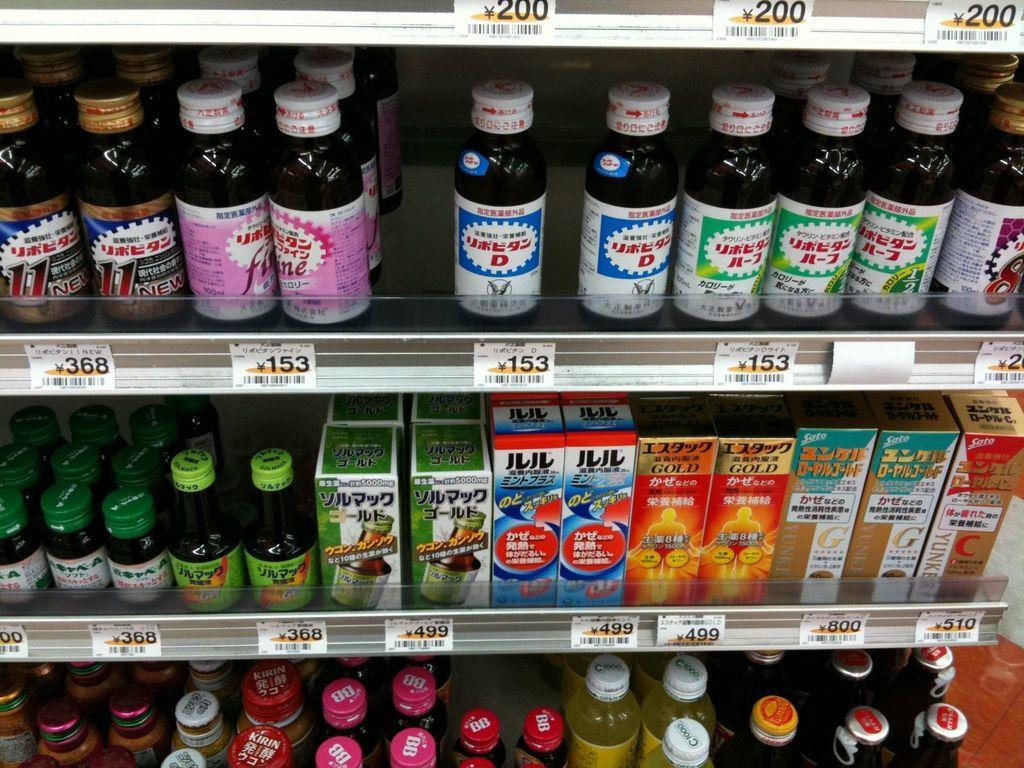How would you summarize this image in a sentence or two? In this picture we can see some bottles and boxes which are arranged in the rack. In front of different kind of bottles we can see different numbers. 